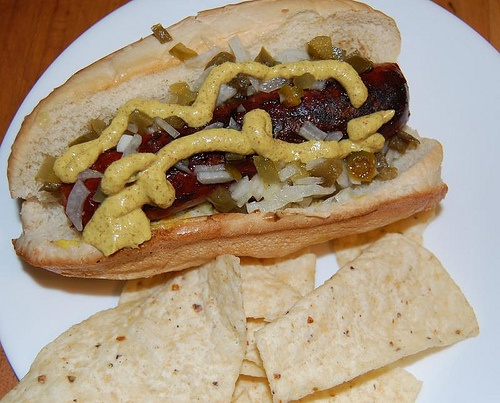Describe the objects in this image and their specific colors. I can see a hot dog in maroon, tan, olive, and black tones in this image. 